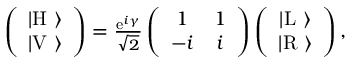Convert formula to latex. <formula><loc_0><loc_0><loc_500><loc_500>\begin{array} { r } { \left ( \begin{array} { c } { | H \ \rangle } \\ { | V \ \rangle } \end{array} \right ) = \frac { e ^ { i \gamma } } { \sqrt { 2 } } \left ( \begin{array} { c c } { 1 } & { 1 } \\ { - i } & { i } \end{array} \right ) \left ( \begin{array} { c } { | L \ \rangle } \\ { | R \ \rangle } \end{array} \right ) , } \end{array}</formula> 